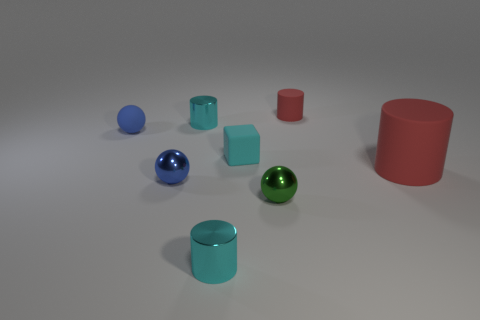Subtract 1 cylinders. How many cylinders are left? 3 Add 1 large brown metal objects. How many objects exist? 9 Subtract all blocks. How many objects are left? 7 Subtract 0 yellow blocks. How many objects are left? 8 Subtract all blue spheres. Subtract all tiny yellow metal cubes. How many objects are left? 6 Add 7 tiny red things. How many tiny red things are left? 8 Add 4 green spheres. How many green spheres exist? 5 